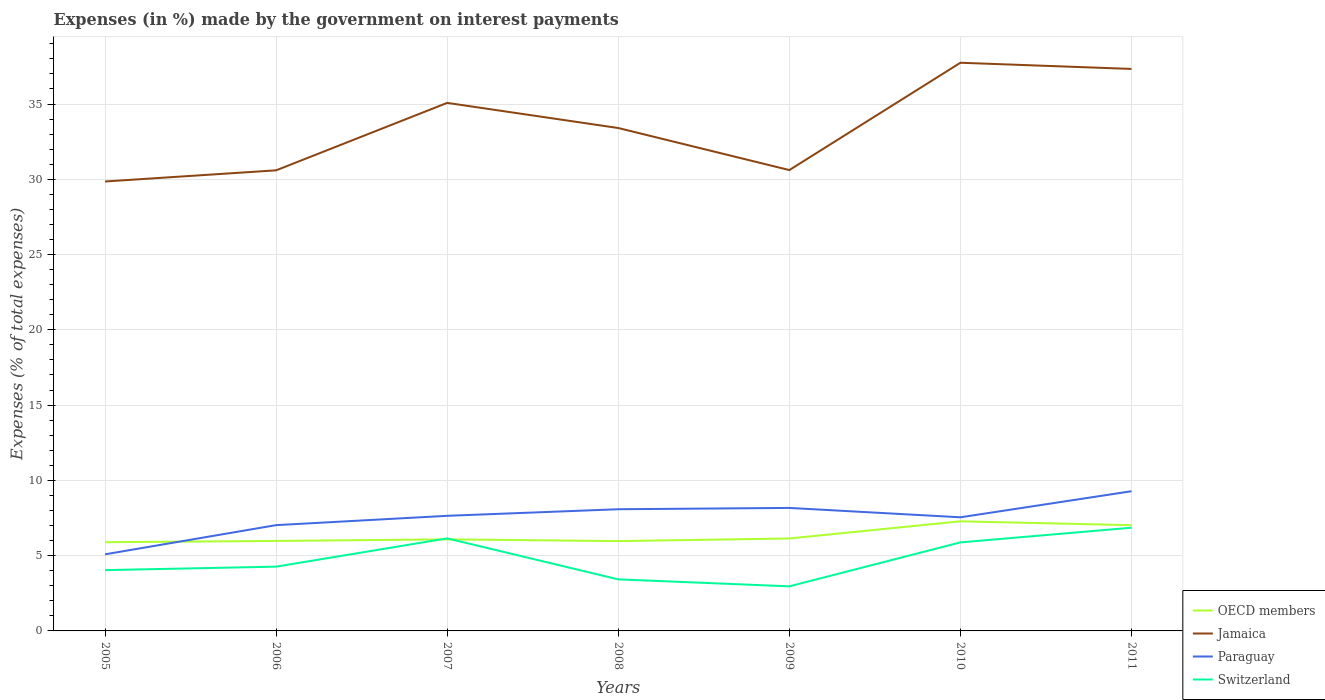How many different coloured lines are there?
Your response must be concise. 4. Does the line corresponding to Jamaica intersect with the line corresponding to Paraguay?
Provide a succinct answer. No. Is the number of lines equal to the number of legend labels?
Keep it short and to the point. Yes. Across all years, what is the maximum percentage of expenses made by the government on interest payments in OECD members?
Provide a short and direct response. 5.89. What is the total percentage of expenses made by the government on interest payments in Jamaica in the graph?
Provide a succinct answer. -7.15. What is the difference between the highest and the second highest percentage of expenses made by the government on interest payments in Switzerland?
Your response must be concise. 3.89. What is the difference between the highest and the lowest percentage of expenses made by the government on interest payments in Switzerland?
Ensure brevity in your answer.  3. Is the percentage of expenses made by the government on interest payments in OECD members strictly greater than the percentage of expenses made by the government on interest payments in Switzerland over the years?
Make the answer very short. No. How many lines are there?
Ensure brevity in your answer.  4. How many years are there in the graph?
Your answer should be very brief. 7. What is the difference between two consecutive major ticks on the Y-axis?
Your answer should be very brief. 5. Are the values on the major ticks of Y-axis written in scientific E-notation?
Your response must be concise. No. Does the graph contain any zero values?
Provide a succinct answer. No. Does the graph contain grids?
Offer a very short reply. Yes. What is the title of the graph?
Keep it short and to the point. Expenses (in %) made by the government on interest payments. Does "Central African Republic" appear as one of the legend labels in the graph?
Your answer should be very brief. No. What is the label or title of the X-axis?
Ensure brevity in your answer.  Years. What is the label or title of the Y-axis?
Your response must be concise. Expenses (% of total expenses). What is the Expenses (% of total expenses) of OECD members in 2005?
Keep it short and to the point. 5.89. What is the Expenses (% of total expenses) in Jamaica in 2005?
Ensure brevity in your answer.  29.85. What is the Expenses (% of total expenses) in Paraguay in 2005?
Your answer should be very brief. 5.09. What is the Expenses (% of total expenses) of Switzerland in 2005?
Make the answer very short. 4.04. What is the Expenses (% of total expenses) in OECD members in 2006?
Provide a succinct answer. 5.98. What is the Expenses (% of total expenses) in Jamaica in 2006?
Offer a terse response. 30.6. What is the Expenses (% of total expenses) of Paraguay in 2006?
Keep it short and to the point. 7.03. What is the Expenses (% of total expenses) of Switzerland in 2006?
Your answer should be very brief. 4.27. What is the Expenses (% of total expenses) in OECD members in 2007?
Offer a terse response. 6.08. What is the Expenses (% of total expenses) of Jamaica in 2007?
Offer a terse response. 35.08. What is the Expenses (% of total expenses) of Paraguay in 2007?
Provide a succinct answer. 7.65. What is the Expenses (% of total expenses) in Switzerland in 2007?
Offer a terse response. 6.15. What is the Expenses (% of total expenses) of OECD members in 2008?
Offer a terse response. 5.97. What is the Expenses (% of total expenses) in Jamaica in 2008?
Your response must be concise. 33.41. What is the Expenses (% of total expenses) in Paraguay in 2008?
Your response must be concise. 8.08. What is the Expenses (% of total expenses) in Switzerland in 2008?
Keep it short and to the point. 3.42. What is the Expenses (% of total expenses) of OECD members in 2009?
Keep it short and to the point. 6.14. What is the Expenses (% of total expenses) in Jamaica in 2009?
Offer a terse response. 30.61. What is the Expenses (% of total expenses) of Paraguay in 2009?
Your response must be concise. 8.17. What is the Expenses (% of total expenses) in Switzerland in 2009?
Give a very brief answer. 2.96. What is the Expenses (% of total expenses) of OECD members in 2010?
Your answer should be very brief. 7.28. What is the Expenses (% of total expenses) of Jamaica in 2010?
Provide a succinct answer. 37.74. What is the Expenses (% of total expenses) of Paraguay in 2010?
Your answer should be compact. 7.55. What is the Expenses (% of total expenses) of Switzerland in 2010?
Give a very brief answer. 5.88. What is the Expenses (% of total expenses) of OECD members in 2011?
Make the answer very short. 7.02. What is the Expenses (% of total expenses) in Jamaica in 2011?
Provide a succinct answer. 37.33. What is the Expenses (% of total expenses) of Paraguay in 2011?
Provide a succinct answer. 9.28. What is the Expenses (% of total expenses) in Switzerland in 2011?
Your answer should be compact. 6.86. Across all years, what is the maximum Expenses (% of total expenses) in OECD members?
Keep it short and to the point. 7.28. Across all years, what is the maximum Expenses (% of total expenses) of Jamaica?
Offer a terse response. 37.74. Across all years, what is the maximum Expenses (% of total expenses) in Paraguay?
Ensure brevity in your answer.  9.28. Across all years, what is the maximum Expenses (% of total expenses) of Switzerland?
Your answer should be compact. 6.86. Across all years, what is the minimum Expenses (% of total expenses) in OECD members?
Ensure brevity in your answer.  5.89. Across all years, what is the minimum Expenses (% of total expenses) of Jamaica?
Your answer should be compact. 29.85. Across all years, what is the minimum Expenses (% of total expenses) in Paraguay?
Offer a terse response. 5.09. Across all years, what is the minimum Expenses (% of total expenses) in Switzerland?
Keep it short and to the point. 2.96. What is the total Expenses (% of total expenses) in OECD members in the graph?
Ensure brevity in your answer.  44.37. What is the total Expenses (% of total expenses) in Jamaica in the graph?
Your response must be concise. 234.62. What is the total Expenses (% of total expenses) of Paraguay in the graph?
Keep it short and to the point. 52.84. What is the total Expenses (% of total expenses) in Switzerland in the graph?
Provide a short and direct response. 33.58. What is the difference between the Expenses (% of total expenses) in OECD members in 2005 and that in 2006?
Offer a very short reply. -0.08. What is the difference between the Expenses (% of total expenses) in Jamaica in 2005 and that in 2006?
Offer a very short reply. -0.74. What is the difference between the Expenses (% of total expenses) of Paraguay in 2005 and that in 2006?
Offer a terse response. -1.94. What is the difference between the Expenses (% of total expenses) of Switzerland in 2005 and that in 2006?
Your answer should be compact. -0.23. What is the difference between the Expenses (% of total expenses) in OECD members in 2005 and that in 2007?
Make the answer very short. -0.19. What is the difference between the Expenses (% of total expenses) of Jamaica in 2005 and that in 2007?
Offer a terse response. -5.22. What is the difference between the Expenses (% of total expenses) in Paraguay in 2005 and that in 2007?
Offer a terse response. -2.56. What is the difference between the Expenses (% of total expenses) in Switzerland in 2005 and that in 2007?
Make the answer very short. -2.11. What is the difference between the Expenses (% of total expenses) in OECD members in 2005 and that in 2008?
Ensure brevity in your answer.  -0.07. What is the difference between the Expenses (% of total expenses) in Jamaica in 2005 and that in 2008?
Your answer should be very brief. -3.55. What is the difference between the Expenses (% of total expenses) of Paraguay in 2005 and that in 2008?
Your response must be concise. -3. What is the difference between the Expenses (% of total expenses) in Switzerland in 2005 and that in 2008?
Offer a very short reply. 0.61. What is the difference between the Expenses (% of total expenses) of OECD members in 2005 and that in 2009?
Your answer should be compact. -0.25. What is the difference between the Expenses (% of total expenses) in Jamaica in 2005 and that in 2009?
Your answer should be compact. -0.76. What is the difference between the Expenses (% of total expenses) in Paraguay in 2005 and that in 2009?
Provide a short and direct response. -3.08. What is the difference between the Expenses (% of total expenses) of Switzerland in 2005 and that in 2009?
Ensure brevity in your answer.  1.08. What is the difference between the Expenses (% of total expenses) in OECD members in 2005 and that in 2010?
Your answer should be very brief. -1.39. What is the difference between the Expenses (% of total expenses) in Jamaica in 2005 and that in 2010?
Give a very brief answer. -7.89. What is the difference between the Expenses (% of total expenses) of Paraguay in 2005 and that in 2010?
Keep it short and to the point. -2.46. What is the difference between the Expenses (% of total expenses) of Switzerland in 2005 and that in 2010?
Ensure brevity in your answer.  -1.84. What is the difference between the Expenses (% of total expenses) in OECD members in 2005 and that in 2011?
Your answer should be compact. -1.13. What is the difference between the Expenses (% of total expenses) of Jamaica in 2005 and that in 2011?
Give a very brief answer. -7.48. What is the difference between the Expenses (% of total expenses) of Paraguay in 2005 and that in 2011?
Keep it short and to the point. -4.19. What is the difference between the Expenses (% of total expenses) in Switzerland in 2005 and that in 2011?
Keep it short and to the point. -2.82. What is the difference between the Expenses (% of total expenses) in OECD members in 2006 and that in 2007?
Keep it short and to the point. -0.1. What is the difference between the Expenses (% of total expenses) of Jamaica in 2006 and that in 2007?
Offer a very short reply. -4.48. What is the difference between the Expenses (% of total expenses) in Paraguay in 2006 and that in 2007?
Provide a succinct answer. -0.62. What is the difference between the Expenses (% of total expenses) of Switzerland in 2006 and that in 2007?
Give a very brief answer. -1.88. What is the difference between the Expenses (% of total expenses) in OECD members in 2006 and that in 2008?
Make the answer very short. 0.01. What is the difference between the Expenses (% of total expenses) in Jamaica in 2006 and that in 2008?
Your answer should be very brief. -2.81. What is the difference between the Expenses (% of total expenses) in Paraguay in 2006 and that in 2008?
Give a very brief answer. -1.06. What is the difference between the Expenses (% of total expenses) of Switzerland in 2006 and that in 2008?
Your answer should be compact. 0.84. What is the difference between the Expenses (% of total expenses) of OECD members in 2006 and that in 2009?
Ensure brevity in your answer.  -0.16. What is the difference between the Expenses (% of total expenses) of Jamaica in 2006 and that in 2009?
Your response must be concise. -0.02. What is the difference between the Expenses (% of total expenses) of Paraguay in 2006 and that in 2009?
Your response must be concise. -1.14. What is the difference between the Expenses (% of total expenses) in Switzerland in 2006 and that in 2009?
Give a very brief answer. 1.31. What is the difference between the Expenses (% of total expenses) in OECD members in 2006 and that in 2010?
Keep it short and to the point. -1.3. What is the difference between the Expenses (% of total expenses) in Jamaica in 2006 and that in 2010?
Ensure brevity in your answer.  -7.15. What is the difference between the Expenses (% of total expenses) of Paraguay in 2006 and that in 2010?
Offer a very short reply. -0.52. What is the difference between the Expenses (% of total expenses) in Switzerland in 2006 and that in 2010?
Your response must be concise. -1.61. What is the difference between the Expenses (% of total expenses) of OECD members in 2006 and that in 2011?
Offer a very short reply. -1.05. What is the difference between the Expenses (% of total expenses) in Jamaica in 2006 and that in 2011?
Provide a succinct answer. -6.74. What is the difference between the Expenses (% of total expenses) of Paraguay in 2006 and that in 2011?
Give a very brief answer. -2.25. What is the difference between the Expenses (% of total expenses) of Switzerland in 2006 and that in 2011?
Your response must be concise. -2.59. What is the difference between the Expenses (% of total expenses) of OECD members in 2007 and that in 2008?
Provide a succinct answer. 0.12. What is the difference between the Expenses (% of total expenses) in Jamaica in 2007 and that in 2008?
Keep it short and to the point. 1.67. What is the difference between the Expenses (% of total expenses) in Paraguay in 2007 and that in 2008?
Provide a succinct answer. -0.44. What is the difference between the Expenses (% of total expenses) in Switzerland in 2007 and that in 2008?
Your answer should be compact. 2.72. What is the difference between the Expenses (% of total expenses) in OECD members in 2007 and that in 2009?
Provide a succinct answer. -0.06. What is the difference between the Expenses (% of total expenses) of Jamaica in 2007 and that in 2009?
Give a very brief answer. 4.46. What is the difference between the Expenses (% of total expenses) in Paraguay in 2007 and that in 2009?
Your response must be concise. -0.52. What is the difference between the Expenses (% of total expenses) in Switzerland in 2007 and that in 2009?
Make the answer very short. 3.19. What is the difference between the Expenses (% of total expenses) of OECD members in 2007 and that in 2010?
Provide a short and direct response. -1.2. What is the difference between the Expenses (% of total expenses) in Jamaica in 2007 and that in 2010?
Keep it short and to the point. -2.67. What is the difference between the Expenses (% of total expenses) in Paraguay in 2007 and that in 2010?
Give a very brief answer. 0.1. What is the difference between the Expenses (% of total expenses) of Switzerland in 2007 and that in 2010?
Make the answer very short. 0.27. What is the difference between the Expenses (% of total expenses) of OECD members in 2007 and that in 2011?
Your response must be concise. -0.94. What is the difference between the Expenses (% of total expenses) of Jamaica in 2007 and that in 2011?
Provide a succinct answer. -2.26. What is the difference between the Expenses (% of total expenses) in Paraguay in 2007 and that in 2011?
Offer a very short reply. -1.63. What is the difference between the Expenses (% of total expenses) in Switzerland in 2007 and that in 2011?
Give a very brief answer. -0.71. What is the difference between the Expenses (% of total expenses) of OECD members in 2008 and that in 2009?
Give a very brief answer. -0.18. What is the difference between the Expenses (% of total expenses) in Jamaica in 2008 and that in 2009?
Ensure brevity in your answer.  2.79. What is the difference between the Expenses (% of total expenses) of Paraguay in 2008 and that in 2009?
Offer a terse response. -0.09. What is the difference between the Expenses (% of total expenses) in Switzerland in 2008 and that in 2009?
Offer a very short reply. 0.46. What is the difference between the Expenses (% of total expenses) of OECD members in 2008 and that in 2010?
Give a very brief answer. -1.32. What is the difference between the Expenses (% of total expenses) in Jamaica in 2008 and that in 2010?
Give a very brief answer. -4.34. What is the difference between the Expenses (% of total expenses) in Paraguay in 2008 and that in 2010?
Offer a very short reply. 0.54. What is the difference between the Expenses (% of total expenses) in Switzerland in 2008 and that in 2010?
Your answer should be compact. -2.46. What is the difference between the Expenses (% of total expenses) of OECD members in 2008 and that in 2011?
Offer a very short reply. -1.06. What is the difference between the Expenses (% of total expenses) in Jamaica in 2008 and that in 2011?
Your answer should be very brief. -3.93. What is the difference between the Expenses (% of total expenses) of Paraguay in 2008 and that in 2011?
Keep it short and to the point. -1.2. What is the difference between the Expenses (% of total expenses) of Switzerland in 2008 and that in 2011?
Ensure brevity in your answer.  -3.43. What is the difference between the Expenses (% of total expenses) in OECD members in 2009 and that in 2010?
Offer a terse response. -1.14. What is the difference between the Expenses (% of total expenses) in Jamaica in 2009 and that in 2010?
Offer a terse response. -7.13. What is the difference between the Expenses (% of total expenses) of Paraguay in 2009 and that in 2010?
Your response must be concise. 0.62. What is the difference between the Expenses (% of total expenses) of Switzerland in 2009 and that in 2010?
Provide a succinct answer. -2.92. What is the difference between the Expenses (% of total expenses) of OECD members in 2009 and that in 2011?
Offer a very short reply. -0.88. What is the difference between the Expenses (% of total expenses) of Jamaica in 2009 and that in 2011?
Give a very brief answer. -6.72. What is the difference between the Expenses (% of total expenses) of Paraguay in 2009 and that in 2011?
Offer a terse response. -1.11. What is the difference between the Expenses (% of total expenses) of Switzerland in 2009 and that in 2011?
Your response must be concise. -3.89. What is the difference between the Expenses (% of total expenses) in OECD members in 2010 and that in 2011?
Provide a short and direct response. 0.26. What is the difference between the Expenses (% of total expenses) in Jamaica in 2010 and that in 2011?
Your answer should be compact. 0.41. What is the difference between the Expenses (% of total expenses) in Paraguay in 2010 and that in 2011?
Keep it short and to the point. -1.73. What is the difference between the Expenses (% of total expenses) of Switzerland in 2010 and that in 2011?
Make the answer very short. -0.97. What is the difference between the Expenses (% of total expenses) in OECD members in 2005 and the Expenses (% of total expenses) in Jamaica in 2006?
Ensure brevity in your answer.  -24.7. What is the difference between the Expenses (% of total expenses) of OECD members in 2005 and the Expenses (% of total expenses) of Paraguay in 2006?
Your response must be concise. -1.13. What is the difference between the Expenses (% of total expenses) of OECD members in 2005 and the Expenses (% of total expenses) of Switzerland in 2006?
Offer a very short reply. 1.62. What is the difference between the Expenses (% of total expenses) of Jamaica in 2005 and the Expenses (% of total expenses) of Paraguay in 2006?
Offer a terse response. 22.83. What is the difference between the Expenses (% of total expenses) of Jamaica in 2005 and the Expenses (% of total expenses) of Switzerland in 2006?
Your answer should be compact. 25.58. What is the difference between the Expenses (% of total expenses) of Paraguay in 2005 and the Expenses (% of total expenses) of Switzerland in 2006?
Ensure brevity in your answer.  0.82. What is the difference between the Expenses (% of total expenses) in OECD members in 2005 and the Expenses (% of total expenses) in Jamaica in 2007?
Offer a very short reply. -29.18. What is the difference between the Expenses (% of total expenses) in OECD members in 2005 and the Expenses (% of total expenses) in Paraguay in 2007?
Your answer should be compact. -1.75. What is the difference between the Expenses (% of total expenses) in OECD members in 2005 and the Expenses (% of total expenses) in Switzerland in 2007?
Ensure brevity in your answer.  -0.25. What is the difference between the Expenses (% of total expenses) of Jamaica in 2005 and the Expenses (% of total expenses) of Paraguay in 2007?
Your response must be concise. 22.21. What is the difference between the Expenses (% of total expenses) in Jamaica in 2005 and the Expenses (% of total expenses) in Switzerland in 2007?
Ensure brevity in your answer.  23.71. What is the difference between the Expenses (% of total expenses) of Paraguay in 2005 and the Expenses (% of total expenses) of Switzerland in 2007?
Your answer should be compact. -1.06. What is the difference between the Expenses (% of total expenses) of OECD members in 2005 and the Expenses (% of total expenses) of Jamaica in 2008?
Your answer should be compact. -27.51. What is the difference between the Expenses (% of total expenses) in OECD members in 2005 and the Expenses (% of total expenses) in Paraguay in 2008?
Keep it short and to the point. -2.19. What is the difference between the Expenses (% of total expenses) of OECD members in 2005 and the Expenses (% of total expenses) of Switzerland in 2008?
Give a very brief answer. 2.47. What is the difference between the Expenses (% of total expenses) of Jamaica in 2005 and the Expenses (% of total expenses) of Paraguay in 2008?
Make the answer very short. 21.77. What is the difference between the Expenses (% of total expenses) of Jamaica in 2005 and the Expenses (% of total expenses) of Switzerland in 2008?
Provide a succinct answer. 26.43. What is the difference between the Expenses (% of total expenses) in Paraguay in 2005 and the Expenses (% of total expenses) in Switzerland in 2008?
Your response must be concise. 1.66. What is the difference between the Expenses (% of total expenses) of OECD members in 2005 and the Expenses (% of total expenses) of Jamaica in 2009?
Ensure brevity in your answer.  -24.72. What is the difference between the Expenses (% of total expenses) of OECD members in 2005 and the Expenses (% of total expenses) of Paraguay in 2009?
Make the answer very short. -2.28. What is the difference between the Expenses (% of total expenses) of OECD members in 2005 and the Expenses (% of total expenses) of Switzerland in 2009?
Keep it short and to the point. 2.93. What is the difference between the Expenses (% of total expenses) in Jamaica in 2005 and the Expenses (% of total expenses) in Paraguay in 2009?
Provide a short and direct response. 21.68. What is the difference between the Expenses (% of total expenses) in Jamaica in 2005 and the Expenses (% of total expenses) in Switzerland in 2009?
Give a very brief answer. 26.89. What is the difference between the Expenses (% of total expenses) of Paraguay in 2005 and the Expenses (% of total expenses) of Switzerland in 2009?
Ensure brevity in your answer.  2.13. What is the difference between the Expenses (% of total expenses) in OECD members in 2005 and the Expenses (% of total expenses) in Jamaica in 2010?
Offer a terse response. -31.85. What is the difference between the Expenses (% of total expenses) in OECD members in 2005 and the Expenses (% of total expenses) in Paraguay in 2010?
Offer a very short reply. -1.65. What is the difference between the Expenses (% of total expenses) of OECD members in 2005 and the Expenses (% of total expenses) of Switzerland in 2010?
Ensure brevity in your answer.  0.01. What is the difference between the Expenses (% of total expenses) in Jamaica in 2005 and the Expenses (% of total expenses) in Paraguay in 2010?
Your answer should be very brief. 22.31. What is the difference between the Expenses (% of total expenses) of Jamaica in 2005 and the Expenses (% of total expenses) of Switzerland in 2010?
Make the answer very short. 23.97. What is the difference between the Expenses (% of total expenses) in Paraguay in 2005 and the Expenses (% of total expenses) in Switzerland in 2010?
Ensure brevity in your answer.  -0.79. What is the difference between the Expenses (% of total expenses) in OECD members in 2005 and the Expenses (% of total expenses) in Jamaica in 2011?
Give a very brief answer. -31.44. What is the difference between the Expenses (% of total expenses) in OECD members in 2005 and the Expenses (% of total expenses) in Paraguay in 2011?
Provide a short and direct response. -3.39. What is the difference between the Expenses (% of total expenses) of OECD members in 2005 and the Expenses (% of total expenses) of Switzerland in 2011?
Provide a succinct answer. -0.96. What is the difference between the Expenses (% of total expenses) of Jamaica in 2005 and the Expenses (% of total expenses) of Paraguay in 2011?
Keep it short and to the point. 20.57. What is the difference between the Expenses (% of total expenses) of Jamaica in 2005 and the Expenses (% of total expenses) of Switzerland in 2011?
Offer a very short reply. 23. What is the difference between the Expenses (% of total expenses) in Paraguay in 2005 and the Expenses (% of total expenses) in Switzerland in 2011?
Keep it short and to the point. -1.77. What is the difference between the Expenses (% of total expenses) of OECD members in 2006 and the Expenses (% of total expenses) of Jamaica in 2007?
Your answer should be very brief. -29.1. What is the difference between the Expenses (% of total expenses) of OECD members in 2006 and the Expenses (% of total expenses) of Paraguay in 2007?
Your answer should be compact. -1.67. What is the difference between the Expenses (% of total expenses) in OECD members in 2006 and the Expenses (% of total expenses) in Switzerland in 2007?
Offer a terse response. -0.17. What is the difference between the Expenses (% of total expenses) in Jamaica in 2006 and the Expenses (% of total expenses) in Paraguay in 2007?
Provide a short and direct response. 22.95. What is the difference between the Expenses (% of total expenses) in Jamaica in 2006 and the Expenses (% of total expenses) in Switzerland in 2007?
Your response must be concise. 24.45. What is the difference between the Expenses (% of total expenses) of Paraguay in 2006 and the Expenses (% of total expenses) of Switzerland in 2007?
Your response must be concise. 0.88. What is the difference between the Expenses (% of total expenses) in OECD members in 2006 and the Expenses (% of total expenses) in Jamaica in 2008?
Your answer should be very brief. -27.43. What is the difference between the Expenses (% of total expenses) in OECD members in 2006 and the Expenses (% of total expenses) in Paraguay in 2008?
Your response must be concise. -2.11. What is the difference between the Expenses (% of total expenses) of OECD members in 2006 and the Expenses (% of total expenses) of Switzerland in 2008?
Ensure brevity in your answer.  2.55. What is the difference between the Expenses (% of total expenses) of Jamaica in 2006 and the Expenses (% of total expenses) of Paraguay in 2008?
Ensure brevity in your answer.  22.51. What is the difference between the Expenses (% of total expenses) of Jamaica in 2006 and the Expenses (% of total expenses) of Switzerland in 2008?
Keep it short and to the point. 27.17. What is the difference between the Expenses (% of total expenses) of Paraguay in 2006 and the Expenses (% of total expenses) of Switzerland in 2008?
Provide a short and direct response. 3.6. What is the difference between the Expenses (% of total expenses) of OECD members in 2006 and the Expenses (% of total expenses) of Jamaica in 2009?
Your answer should be compact. -24.64. What is the difference between the Expenses (% of total expenses) in OECD members in 2006 and the Expenses (% of total expenses) in Paraguay in 2009?
Provide a short and direct response. -2.19. What is the difference between the Expenses (% of total expenses) of OECD members in 2006 and the Expenses (% of total expenses) of Switzerland in 2009?
Make the answer very short. 3.02. What is the difference between the Expenses (% of total expenses) in Jamaica in 2006 and the Expenses (% of total expenses) in Paraguay in 2009?
Keep it short and to the point. 22.43. What is the difference between the Expenses (% of total expenses) in Jamaica in 2006 and the Expenses (% of total expenses) in Switzerland in 2009?
Offer a terse response. 27.63. What is the difference between the Expenses (% of total expenses) of Paraguay in 2006 and the Expenses (% of total expenses) of Switzerland in 2009?
Make the answer very short. 4.07. What is the difference between the Expenses (% of total expenses) in OECD members in 2006 and the Expenses (% of total expenses) in Jamaica in 2010?
Your response must be concise. -31.76. What is the difference between the Expenses (% of total expenses) of OECD members in 2006 and the Expenses (% of total expenses) of Paraguay in 2010?
Offer a very short reply. -1.57. What is the difference between the Expenses (% of total expenses) in OECD members in 2006 and the Expenses (% of total expenses) in Switzerland in 2010?
Offer a terse response. 0.1. What is the difference between the Expenses (% of total expenses) of Jamaica in 2006 and the Expenses (% of total expenses) of Paraguay in 2010?
Provide a short and direct response. 23.05. What is the difference between the Expenses (% of total expenses) of Jamaica in 2006 and the Expenses (% of total expenses) of Switzerland in 2010?
Provide a succinct answer. 24.71. What is the difference between the Expenses (% of total expenses) in Paraguay in 2006 and the Expenses (% of total expenses) in Switzerland in 2010?
Make the answer very short. 1.15. What is the difference between the Expenses (% of total expenses) in OECD members in 2006 and the Expenses (% of total expenses) in Jamaica in 2011?
Provide a succinct answer. -31.35. What is the difference between the Expenses (% of total expenses) in OECD members in 2006 and the Expenses (% of total expenses) in Paraguay in 2011?
Give a very brief answer. -3.3. What is the difference between the Expenses (% of total expenses) of OECD members in 2006 and the Expenses (% of total expenses) of Switzerland in 2011?
Your answer should be compact. -0.88. What is the difference between the Expenses (% of total expenses) of Jamaica in 2006 and the Expenses (% of total expenses) of Paraguay in 2011?
Provide a short and direct response. 21.32. What is the difference between the Expenses (% of total expenses) of Jamaica in 2006 and the Expenses (% of total expenses) of Switzerland in 2011?
Keep it short and to the point. 23.74. What is the difference between the Expenses (% of total expenses) of Paraguay in 2006 and the Expenses (% of total expenses) of Switzerland in 2011?
Make the answer very short. 0.17. What is the difference between the Expenses (% of total expenses) of OECD members in 2007 and the Expenses (% of total expenses) of Jamaica in 2008?
Your answer should be very brief. -27.32. What is the difference between the Expenses (% of total expenses) of OECD members in 2007 and the Expenses (% of total expenses) of Paraguay in 2008?
Provide a short and direct response. -2. What is the difference between the Expenses (% of total expenses) in OECD members in 2007 and the Expenses (% of total expenses) in Switzerland in 2008?
Offer a terse response. 2.66. What is the difference between the Expenses (% of total expenses) of Jamaica in 2007 and the Expenses (% of total expenses) of Paraguay in 2008?
Offer a terse response. 26.99. What is the difference between the Expenses (% of total expenses) in Jamaica in 2007 and the Expenses (% of total expenses) in Switzerland in 2008?
Offer a terse response. 31.65. What is the difference between the Expenses (% of total expenses) of Paraguay in 2007 and the Expenses (% of total expenses) of Switzerland in 2008?
Provide a succinct answer. 4.22. What is the difference between the Expenses (% of total expenses) in OECD members in 2007 and the Expenses (% of total expenses) in Jamaica in 2009?
Your answer should be compact. -24.53. What is the difference between the Expenses (% of total expenses) in OECD members in 2007 and the Expenses (% of total expenses) in Paraguay in 2009?
Give a very brief answer. -2.09. What is the difference between the Expenses (% of total expenses) in OECD members in 2007 and the Expenses (% of total expenses) in Switzerland in 2009?
Ensure brevity in your answer.  3.12. What is the difference between the Expenses (% of total expenses) in Jamaica in 2007 and the Expenses (% of total expenses) in Paraguay in 2009?
Ensure brevity in your answer.  26.91. What is the difference between the Expenses (% of total expenses) in Jamaica in 2007 and the Expenses (% of total expenses) in Switzerland in 2009?
Provide a succinct answer. 32.11. What is the difference between the Expenses (% of total expenses) in Paraguay in 2007 and the Expenses (% of total expenses) in Switzerland in 2009?
Your answer should be compact. 4.68. What is the difference between the Expenses (% of total expenses) in OECD members in 2007 and the Expenses (% of total expenses) in Jamaica in 2010?
Make the answer very short. -31.66. What is the difference between the Expenses (% of total expenses) in OECD members in 2007 and the Expenses (% of total expenses) in Paraguay in 2010?
Offer a very short reply. -1.47. What is the difference between the Expenses (% of total expenses) of OECD members in 2007 and the Expenses (% of total expenses) of Switzerland in 2010?
Your response must be concise. 0.2. What is the difference between the Expenses (% of total expenses) in Jamaica in 2007 and the Expenses (% of total expenses) in Paraguay in 2010?
Offer a very short reply. 27.53. What is the difference between the Expenses (% of total expenses) in Jamaica in 2007 and the Expenses (% of total expenses) in Switzerland in 2010?
Offer a very short reply. 29.19. What is the difference between the Expenses (% of total expenses) of Paraguay in 2007 and the Expenses (% of total expenses) of Switzerland in 2010?
Your answer should be very brief. 1.76. What is the difference between the Expenses (% of total expenses) in OECD members in 2007 and the Expenses (% of total expenses) in Jamaica in 2011?
Your response must be concise. -31.25. What is the difference between the Expenses (% of total expenses) in OECD members in 2007 and the Expenses (% of total expenses) in Paraguay in 2011?
Make the answer very short. -3.2. What is the difference between the Expenses (% of total expenses) in OECD members in 2007 and the Expenses (% of total expenses) in Switzerland in 2011?
Ensure brevity in your answer.  -0.77. What is the difference between the Expenses (% of total expenses) in Jamaica in 2007 and the Expenses (% of total expenses) in Paraguay in 2011?
Ensure brevity in your answer.  25.8. What is the difference between the Expenses (% of total expenses) in Jamaica in 2007 and the Expenses (% of total expenses) in Switzerland in 2011?
Ensure brevity in your answer.  28.22. What is the difference between the Expenses (% of total expenses) in Paraguay in 2007 and the Expenses (% of total expenses) in Switzerland in 2011?
Offer a very short reply. 0.79. What is the difference between the Expenses (% of total expenses) in OECD members in 2008 and the Expenses (% of total expenses) in Jamaica in 2009?
Ensure brevity in your answer.  -24.65. What is the difference between the Expenses (% of total expenses) in OECD members in 2008 and the Expenses (% of total expenses) in Paraguay in 2009?
Provide a succinct answer. -2.2. What is the difference between the Expenses (% of total expenses) of OECD members in 2008 and the Expenses (% of total expenses) of Switzerland in 2009?
Keep it short and to the point. 3. What is the difference between the Expenses (% of total expenses) of Jamaica in 2008 and the Expenses (% of total expenses) of Paraguay in 2009?
Your answer should be compact. 25.24. What is the difference between the Expenses (% of total expenses) in Jamaica in 2008 and the Expenses (% of total expenses) in Switzerland in 2009?
Ensure brevity in your answer.  30.44. What is the difference between the Expenses (% of total expenses) in Paraguay in 2008 and the Expenses (% of total expenses) in Switzerland in 2009?
Your answer should be very brief. 5.12. What is the difference between the Expenses (% of total expenses) of OECD members in 2008 and the Expenses (% of total expenses) of Jamaica in 2010?
Offer a terse response. -31.78. What is the difference between the Expenses (% of total expenses) of OECD members in 2008 and the Expenses (% of total expenses) of Paraguay in 2010?
Keep it short and to the point. -1.58. What is the difference between the Expenses (% of total expenses) of OECD members in 2008 and the Expenses (% of total expenses) of Switzerland in 2010?
Make the answer very short. 0.08. What is the difference between the Expenses (% of total expenses) of Jamaica in 2008 and the Expenses (% of total expenses) of Paraguay in 2010?
Provide a succinct answer. 25.86. What is the difference between the Expenses (% of total expenses) in Jamaica in 2008 and the Expenses (% of total expenses) in Switzerland in 2010?
Keep it short and to the point. 27.52. What is the difference between the Expenses (% of total expenses) in Paraguay in 2008 and the Expenses (% of total expenses) in Switzerland in 2010?
Offer a very short reply. 2.2. What is the difference between the Expenses (% of total expenses) in OECD members in 2008 and the Expenses (% of total expenses) in Jamaica in 2011?
Ensure brevity in your answer.  -31.37. What is the difference between the Expenses (% of total expenses) of OECD members in 2008 and the Expenses (% of total expenses) of Paraguay in 2011?
Offer a very short reply. -3.31. What is the difference between the Expenses (% of total expenses) in OECD members in 2008 and the Expenses (% of total expenses) in Switzerland in 2011?
Your response must be concise. -0.89. What is the difference between the Expenses (% of total expenses) of Jamaica in 2008 and the Expenses (% of total expenses) of Paraguay in 2011?
Your answer should be very brief. 24.13. What is the difference between the Expenses (% of total expenses) of Jamaica in 2008 and the Expenses (% of total expenses) of Switzerland in 2011?
Your answer should be very brief. 26.55. What is the difference between the Expenses (% of total expenses) in Paraguay in 2008 and the Expenses (% of total expenses) in Switzerland in 2011?
Keep it short and to the point. 1.23. What is the difference between the Expenses (% of total expenses) in OECD members in 2009 and the Expenses (% of total expenses) in Jamaica in 2010?
Offer a very short reply. -31.6. What is the difference between the Expenses (% of total expenses) in OECD members in 2009 and the Expenses (% of total expenses) in Paraguay in 2010?
Provide a short and direct response. -1.41. What is the difference between the Expenses (% of total expenses) in OECD members in 2009 and the Expenses (% of total expenses) in Switzerland in 2010?
Provide a short and direct response. 0.26. What is the difference between the Expenses (% of total expenses) in Jamaica in 2009 and the Expenses (% of total expenses) in Paraguay in 2010?
Offer a very short reply. 23.06. What is the difference between the Expenses (% of total expenses) in Jamaica in 2009 and the Expenses (% of total expenses) in Switzerland in 2010?
Your response must be concise. 24.73. What is the difference between the Expenses (% of total expenses) of Paraguay in 2009 and the Expenses (% of total expenses) of Switzerland in 2010?
Offer a terse response. 2.29. What is the difference between the Expenses (% of total expenses) in OECD members in 2009 and the Expenses (% of total expenses) in Jamaica in 2011?
Your answer should be very brief. -31.19. What is the difference between the Expenses (% of total expenses) in OECD members in 2009 and the Expenses (% of total expenses) in Paraguay in 2011?
Your answer should be compact. -3.14. What is the difference between the Expenses (% of total expenses) of OECD members in 2009 and the Expenses (% of total expenses) of Switzerland in 2011?
Your response must be concise. -0.71. What is the difference between the Expenses (% of total expenses) in Jamaica in 2009 and the Expenses (% of total expenses) in Paraguay in 2011?
Your response must be concise. 21.33. What is the difference between the Expenses (% of total expenses) in Jamaica in 2009 and the Expenses (% of total expenses) in Switzerland in 2011?
Offer a very short reply. 23.76. What is the difference between the Expenses (% of total expenses) in Paraguay in 2009 and the Expenses (% of total expenses) in Switzerland in 2011?
Your answer should be compact. 1.31. What is the difference between the Expenses (% of total expenses) of OECD members in 2010 and the Expenses (% of total expenses) of Jamaica in 2011?
Ensure brevity in your answer.  -30.05. What is the difference between the Expenses (% of total expenses) of OECD members in 2010 and the Expenses (% of total expenses) of Paraguay in 2011?
Give a very brief answer. -2. What is the difference between the Expenses (% of total expenses) of OECD members in 2010 and the Expenses (% of total expenses) of Switzerland in 2011?
Offer a very short reply. 0.42. What is the difference between the Expenses (% of total expenses) in Jamaica in 2010 and the Expenses (% of total expenses) in Paraguay in 2011?
Give a very brief answer. 28.46. What is the difference between the Expenses (% of total expenses) of Jamaica in 2010 and the Expenses (% of total expenses) of Switzerland in 2011?
Keep it short and to the point. 30.89. What is the difference between the Expenses (% of total expenses) in Paraguay in 2010 and the Expenses (% of total expenses) in Switzerland in 2011?
Ensure brevity in your answer.  0.69. What is the average Expenses (% of total expenses) in OECD members per year?
Provide a succinct answer. 6.34. What is the average Expenses (% of total expenses) of Jamaica per year?
Keep it short and to the point. 33.52. What is the average Expenses (% of total expenses) in Paraguay per year?
Your response must be concise. 7.55. What is the average Expenses (% of total expenses) in Switzerland per year?
Ensure brevity in your answer.  4.8. In the year 2005, what is the difference between the Expenses (% of total expenses) in OECD members and Expenses (% of total expenses) in Jamaica?
Your response must be concise. -23.96. In the year 2005, what is the difference between the Expenses (% of total expenses) in OECD members and Expenses (% of total expenses) in Paraguay?
Your answer should be compact. 0.81. In the year 2005, what is the difference between the Expenses (% of total expenses) in OECD members and Expenses (% of total expenses) in Switzerland?
Ensure brevity in your answer.  1.86. In the year 2005, what is the difference between the Expenses (% of total expenses) of Jamaica and Expenses (% of total expenses) of Paraguay?
Provide a short and direct response. 24.77. In the year 2005, what is the difference between the Expenses (% of total expenses) in Jamaica and Expenses (% of total expenses) in Switzerland?
Provide a short and direct response. 25.82. In the year 2005, what is the difference between the Expenses (% of total expenses) in Paraguay and Expenses (% of total expenses) in Switzerland?
Offer a very short reply. 1.05. In the year 2006, what is the difference between the Expenses (% of total expenses) in OECD members and Expenses (% of total expenses) in Jamaica?
Your answer should be very brief. -24.62. In the year 2006, what is the difference between the Expenses (% of total expenses) of OECD members and Expenses (% of total expenses) of Paraguay?
Provide a short and direct response. -1.05. In the year 2006, what is the difference between the Expenses (% of total expenses) of OECD members and Expenses (% of total expenses) of Switzerland?
Your answer should be compact. 1.71. In the year 2006, what is the difference between the Expenses (% of total expenses) in Jamaica and Expenses (% of total expenses) in Paraguay?
Give a very brief answer. 23.57. In the year 2006, what is the difference between the Expenses (% of total expenses) in Jamaica and Expenses (% of total expenses) in Switzerland?
Keep it short and to the point. 26.33. In the year 2006, what is the difference between the Expenses (% of total expenses) in Paraguay and Expenses (% of total expenses) in Switzerland?
Provide a succinct answer. 2.76. In the year 2007, what is the difference between the Expenses (% of total expenses) of OECD members and Expenses (% of total expenses) of Jamaica?
Provide a short and direct response. -28.99. In the year 2007, what is the difference between the Expenses (% of total expenses) in OECD members and Expenses (% of total expenses) in Paraguay?
Make the answer very short. -1.56. In the year 2007, what is the difference between the Expenses (% of total expenses) in OECD members and Expenses (% of total expenses) in Switzerland?
Your answer should be compact. -0.07. In the year 2007, what is the difference between the Expenses (% of total expenses) in Jamaica and Expenses (% of total expenses) in Paraguay?
Keep it short and to the point. 27.43. In the year 2007, what is the difference between the Expenses (% of total expenses) in Jamaica and Expenses (% of total expenses) in Switzerland?
Give a very brief answer. 28.93. In the year 2007, what is the difference between the Expenses (% of total expenses) in Paraguay and Expenses (% of total expenses) in Switzerland?
Give a very brief answer. 1.5. In the year 2008, what is the difference between the Expenses (% of total expenses) of OECD members and Expenses (% of total expenses) of Jamaica?
Ensure brevity in your answer.  -27.44. In the year 2008, what is the difference between the Expenses (% of total expenses) in OECD members and Expenses (% of total expenses) in Paraguay?
Provide a short and direct response. -2.12. In the year 2008, what is the difference between the Expenses (% of total expenses) in OECD members and Expenses (% of total expenses) in Switzerland?
Provide a succinct answer. 2.54. In the year 2008, what is the difference between the Expenses (% of total expenses) in Jamaica and Expenses (% of total expenses) in Paraguay?
Provide a succinct answer. 25.32. In the year 2008, what is the difference between the Expenses (% of total expenses) in Jamaica and Expenses (% of total expenses) in Switzerland?
Offer a very short reply. 29.98. In the year 2008, what is the difference between the Expenses (% of total expenses) in Paraguay and Expenses (% of total expenses) in Switzerland?
Ensure brevity in your answer.  4.66. In the year 2009, what is the difference between the Expenses (% of total expenses) of OECD members and Expenses (% of total expenses) of Jamaica?
Offer a very short reply. -24.47. In the year 2009, what is the difference between the Expenses (% of total expenses) in OECD members and Expenses (% of total expenses) in Paraguay?
Ensure brevity in your answer.  -2.03. In the year 2009, what is the difference between the Expenses (% of total expenses) of OECD members and Expenses (% of total expenses) of Switzerland?
Give a very brief answer. 3.18. In the year 2009, what is the difference between the Expenses (% of total expenses) of Jamaica and Expenses (% of total expenses) of Paraguay?
Your answer should be very brief. 22.44. In the year 2009, what is the difference between the Expenses (% of total expenses) of Jamaica and Expenses (% of total expenses) of Switzerland?
Your answer should be very brief. 27.65. In the year 2009, what is the difference between the Expenses (% of total expenses) of Paraguay and Expenses (% of total expenses) of Switzerland?
Your answer should be very brief. 5.21. In the year 2010, what is the difference between the Expenses (% of total expenses) of OECD members and Expenses (% of total expenses) of Jamaica?
Your answer should be very brief. -30.46. In the year 2010, what is the difference between the Expenses (% of total expenses) of OECD members and Expenses (% of total expenses) of Paraguay?
Your response must be concise. -0.27. In the year 2010, what is the difference between the Expenses (% of total expenses) of OECD members and Expenses (% of total expenses) of Switzerland?
Your answer should be compact. 1.4. In the year 2010, what is the difference between the Expenses (% of total expenses) in Jamaica and Expenses (% of total expenses) in Paraguay?
Offer a very short reply. 30.19. In the year 2010, what is the difference between the Expenses (% of total expenses) in Jamaica and Expenses (% of total expenses) in Switzerland?
Keep it short and to the point. 31.86. In the year 2010, what is the difference between the Expenses (% of total expenses) in Paraguay and Expenses (% of total expenses) in Switzerland?
Your response must be concise. 1.67. In the year 2011, what is the difference between the Expenses (% of total expenses) of OECD members and Expenses (% of total expenses) of Jamaica?
Give a very brief answer. -30.31. In the year 2011, what is the difference between the Expenses (% of total expenses) in OECD members and Expenses (% of total expenses) in Paraguay?
Your response must be concise. -2.26. In the year 2011, what is the difference between the Expenses (% of total expenses) of OECD members and Expenses (% of total expenses) of Switzerland?
Give a very brief answer. 0.17. In the year 2011, what is the difference between the Expenses (% of total expenses) of Jamaica and Expenses (% of total expenses) of Paraguay?
Offer a terse response. 28.05. In the year 2011, what is the difference between the Expenses (% of total expenses) in Jamaica and Expenses (% of total expenses) in Switzerland?
Provide a succinct answer. 30.47. In the year 2011, what is the difference between the Expenses (% of total expenses) in Paraguay and Expenses (% of total expenses) in Switzerland?
Give a very brief answer. 2.42. What is the ratio of the Expenses (% of total expenses) in OECD members in 2005 to that in 2006?
Offer a very short reply. 0.99. What is the ratio of the Expenses (% of total expenses) of Jamaica in 2005 to that in 2006?
Your answer should be very brief. 0.98. What is the ratio of the Expenses (% of total expenses) of Paraguay in 2005 to that in 2006?
Your response must be concise. 0.72. What is the ratio of the Expenses (% of total expenses) in Switzerland in 2005 to that in 2006?
Provide a short and direct response. 0.95. What is the ratio of the Expenses (% of total expenses) of OECD members in 2005 to that in 2007?
Provide a succinct answer. 0.97. What is the ratio of the Expenses (% of total expenses) in Jamaica in 2005 to that in 2007?
Provide a short and direct response. 0.85. What is the ratio of the Expenses (% of total expenses) in Paraguay in 2005 to that in 2007?
Your answer should be very brief. 0.67. What is the ratio of the Expenses (% of total expenses) of Switzerland in 2005 to that in 2007?
Make the answer very short. 0.66. What is the ratio of the Expenses (% of total expenses) of Jamaica in 2005 to that in 2008?
Provide a succinct answer. 0.89. What is the ratio of the Expenses (% of total expenses) in Paraguay in 2005 to that in 2008?
Your answer should be very brief. 0.63. What is the ratio of the Expenses (% of total expenses) of Switzerland in 2005 to that in 2008?
Keep it short and to the point. 1.18. What is the ratio of the Expenses (% of total expenses) in OECD members in 2005 to that in 2009?
Make the answer very short. 0.96. What is the ratio of the Expenses (% of total expenses) of Jamaica in 2005 to that in 2009?
Keep it short and to the point. 0.98. What is the ratio of the Expenses (% of total expenses) in Paraguay in 2005 to that in 2009?
Provide a succinct answer. 0.62. What is the ratio of the Expenses (% of total expenses) of Switzerland in 2005 to that in 2009?
Your response must be concise. 1.36. What is the ratio of the Expenses (% of total expenses) of OECD members in 2005 to that in 2010?
Offer a very short reply. 0.81. What is the ratio of the Expenses (% of total expenses) in Jamaica in 2005 to that in 2010?
Offer a terse response. 0.79. What is the ratio of the Expenses (% of total expenses) in Paraguay in 2005 to that in 2010?
Offer a very short reply. 0.67. What is the ratio of the Expenses (% of total expenses) of Switzerland in 2005 to that in 2010?
Offer a terse response. 0.69. What is the ratio of the Expenses (% of total expenses) of OECD members in 2005 to that in 2011?
Offer a terse response. 0.84. What is the ratio of the Expenses (% of total expenses) in Jamaica in 2005 to that in 2011?
Ensure brevity in your answer.  0.8. What is the ratio of the Expenses (% of total expenses) of Paraguay in 2005 to that in 2011?
Provide a succinct answer. 0.55. What is the ratio of the Expenses (% of total expenses) of Switzerland in 2005 to that in 2011?
Offer a terse response. 0.59. What is the ratio of the Expenses (% of total expenses) of OECD members in 2006 to that in 2007?
Your response must be concise. 0.98. What is the ratio of the Expenses (% of total expenses) in Jamaica in 2006 to that in 2007?
Your answer should be very brief. 0.87. What is the ratio of the Expenses (% of total expenses) of Paraguay in 2006 to that in 2007?
Your answer should be compact. 0.92. What is the ratio of the Expenses (% of total expenses) of Switzerland in 2006 to that in 2007?
Your answer should be compact. 0.69. What is the ratio of the Expenses (% of total expenses) in Jamaica in 2006 to that in 2008?
Your answer should be compact. 0.92. What is the ratio of the Expenses (% of total expenses) of Paraguay in 2006 to that in 2008?
Offer a terse response. 0.87. What is the ratio of the Expenses (% of total expenses) of Switzerland in 2006 to that in 2008?
Offer a very short reply. 1.25. What is the ratio of the Expenses (% of total expenses) of OECD members in 2006 to that in 2009?
Offer a very short reply. 0.97. What is the ratio of the Expenses (% of total expenses) of Paraguay in 2006 to that in 2009?
Provide a short and direct response. 0.86. What is the ratio of the Expenses (% of total expenses) of Switzerland in 2006 to that in 2009?
Offer a very short reply. 1.44. What is the ratio of the Expenses (% of total expenses) of OECD members in 2006 to that in 2010?
Provide a short and direct response. 0.82. What is the ratio of the Expenses (% of total expenses) in Jamaica in 2006 to that in 2010?
Offer a very short reply. 0.81. What is the ratio of the Expenses (% of total expenses) in Switzerland in 2006 to that in 2010?
Your answer should be compact. 0.73. What is the ratio of the Expenses (% of total expenses) of OECD members in 2006 to that in 2011?
Provide a succinct answer. 0.85. What is the ratio of the Expenses (% of total expenses) in Jamaica in 2006 to that in 2011?
Your response must be concise. 0.82. What is the ratio of the Expenses (% of total expenses) of Paraguay in 2006 to that in 2011?
Provide a short and direct response. 0.76. What is the ratio of the Expenses (% of total expenses) of Switzerland in 2006 to that in 2011?
Your answer should be compact. 0.62. What is the ratio of the Expenses (% of total expenses) of OECD members in 2007 to that in 2008?
Your response must be concise. 1.02. What is the ratio of the Expenses (% of total expenses) of Jamaica in 2007 to that in 2008?
Make the answer very short. 1.05. What is the ratio of the Expenses (% of total expenses) of Paraguay in 2007 to that in 2008?
Your answer should be very brief. 0.95. What is the ratio of the Expenses (% of total expenses) in Switzerland in 2007 to that in 2008?
Provide a short and direct response. 1.79. What is the ratio of the Expenses (% of total expenses) in OECD members in 2007 to that in 2009?
Offer a very short reply. 0.99. What is the ratio of the Expenses (% of total expenses) in Jamaica in 2007 to that in 2009?
Offer a very short reply. 1.15. What is the ratio of the Expenses (% of total expenses) in Paraguay in 2007 to that in 2009?
Keep it short and to the point. 0.94. What is the ratio of the Expenses (% of total expenses) of Switzerland in 2007 to that in 2009?
Ensure brevity in your answer.  2.08. What is the ratio of the Expenses (% of total expenses) of OECD members in 2007 to that in 2010?
Give a very brief answer. 0.84. What is the ratio of the Expenses (% of total expenses) in Jamaica in 2007 to that in 2010?
Your answer should be compact. 0.93. What is the ratio of the Expenses (% of total expenses) of Paraguay in 2007 to that in 2010?
Keep it short and to the point. 1.01. What is the ratio of the Expenses (% of total expenses) in Switzerland in 2007 to that in 2010?
Your response must be concise. 1.05. What is the ratio of the Expenses (% of total expenses) in OECD members in 2007 to that in 2011?
Your answer should be very brief. 0.87. What is the ratio of the Expenses (% of total expenses) in Jamaica in 2007 to that in 2011?
Provide a short and direct response. 0.94. What is the ratio of the Expenses (% of total expenses) of Paraguay in 2007 to that in 2011?
Your answer should be very brief. 0.82. What is the ratio of the Expenses (% of total expenses) in Switzerland in 2007 to that in 2011?
Your answer should be very brief. 0.9. What is the ratio of the Expenses (% of total expenses) in OECD members in 2008 to that in 2009?
Provide a short and direct response. 0.97. What is the ratio of the Expenses (% of total expenses) of Jamaica in 2008 to that in 2009?
Your answer should be very brief. 1.09. What is the ratio of the Expenses (% of total expenses) of Paraguay in 2008 to that in 2009?
Ensure brevity in your answer.  0.99. What is the ratio of the Expenses (% of total expenses) in Switzerland in 2008 to that in 2009?
Provide a succinct answer. 1.16. What is the ratio of the Expenses (% of total expenses) in OECD members in 2008 to that in 2010?
Ensure brevity in your answer.  0.82. What is the ratio of the Expenses (% of total expenses) in Jamaica in 2008 to that in 2010?
Your answer should be very brief. 0.89. What is the ratio of the Expenses (% of total expenses) of Paraguay in 2008 to that in 2010?
Offer a terse response. 1.07. What is the ratio of the Expenses (% of total expenses) of Switzerland in 2008 to that in 2010?
Offer a terse response. 0.58. What is the ratio of the Expenses (% of total expenses) in OECD members in 2008 to that in 2011?
Make the answer very short. 0.85. What is the ratio of the Expenses (% of total expenses) in Jamaica in 2008 to that in 2011?
Your answer should be compact. 0.89. What is the ratio of the Expenses (% of total expenses) of Paraguay in 2008 to that in 2011?
Ensure brevity in your answer.  0.87. What is the ratio of the Expenses (% of total expenses) of Switzerland in 2008 to that in 2011?
Your answer should be compact. 0.5. What is the ratio of the Expenses (% of total expenses) in OECD members in 2009 to that in 2010?
Your answer should be very brief. 0.84. What is the ratio of the Expenses (% of total expenses) in Jamaica in 2009 to that in 2010?
Keep it short and to the point. 0.81. What is the ratio of the Expenses (% of total expenses) in Paraguay in 2009 to that in 2010?
Your answer should be compact. 1.08. What is the ratio of the Expenses (% of total expenses) of Switzerland in 2009 to that in 2010?
Provide a succinct answer. 0.5. What is the ratio of the Expenses (% of total expenses) of OECD members in 2009 to that in 2011?
Offer a very short reply. 0.87. What is the ratio of the Expenses (% of total expenses) of Jamaica in 2009 to that in 2011?
Make the answer very short. 0.82. What is the ratio of the Expenses (% of total expenses) of Paraguay in 2009 to that in 2011?
Your answer should be very brief. 0.88. What is the ratio of the Expenses (% of total expenses) of Switzerland in 2009 to that in 2011?
Your answer should be compact. 0.43. What is the ratio of the Expenses (% of total expenses) of OECD members in 2010 to that in 2011?
Make the answer very short. 1.04. What is the ratio of the Expenses (% of total expenses) in Jamaica in 2010 to that in 2011?
Give a very brief answer. 1.01. What is the ratio of the Expenses (% of total expenses) of Paraguay in 2010 to that in 2011?
Provide a succinct answer. 0.81. What is the ratio of the Expenses (% of total expenses) in Switzerland in 2010 to that in 2011?
Make the answer very short. 0.86. What is the difference between the highest and the second highest Expenses (% of total expenses) of OECD members?
Your answer should be compact. 0.26. What is the difference between the highest and the second highest Expenses (% of total expenses) in Jamaica?
Your answer should be compact. 0.41. What is the difference between the highest and the second highest Expenses (% of total expenses) of Paraguay?
Your answer should be very brief. 1.11. What is the difference between the highest and the second highest Expenses (% of total expenses) in Switzerland?
Offer a terse response. 0.71. What is the difference between the highest and the lowest Expenses (% of total expenses) in OECD members?
Your answer should be compact. 1.39. What is the difference between the highest and the lowest Expenses (% of total expenses) of Jamaica?
Ensure brevity in your answer.  7.89. What is the difference between the highest and the lowest Expenses (% of total expenses) in Paraguay?
Your answer should be very brief. 4.19. What is the difference between the highest and the lowest Expenses (% of total expenses) in Switzerland?
Offer a very short reply. 3.89. 